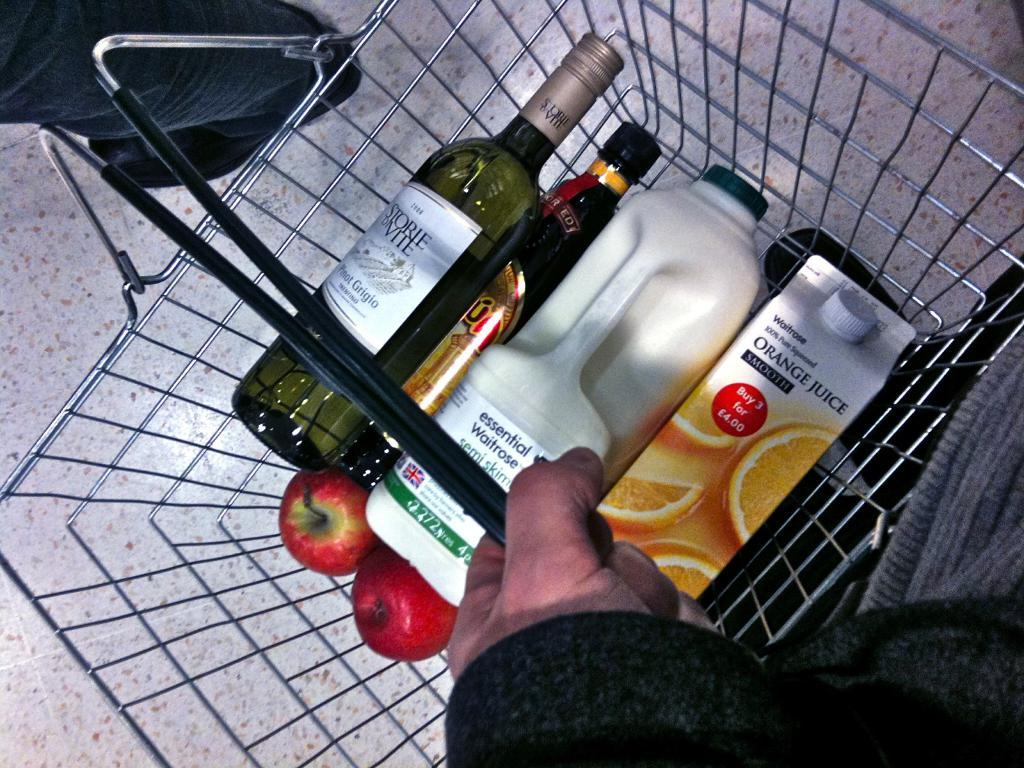What type of objects can be seen in the image? There are bottles, a box, and two apples in the image. Where are these objects located? The objects are in a trolley. Who is carrying the trolley? A person is carrying the trolley. Are there any other people in the image? Yes, there is another person in the image. What example of fire can be seen in the image? There is no example of fire present in the image. How does the son interact with the objects in the image? There is no son present in the image, so it is not possible to describe any interactions with the objects. 